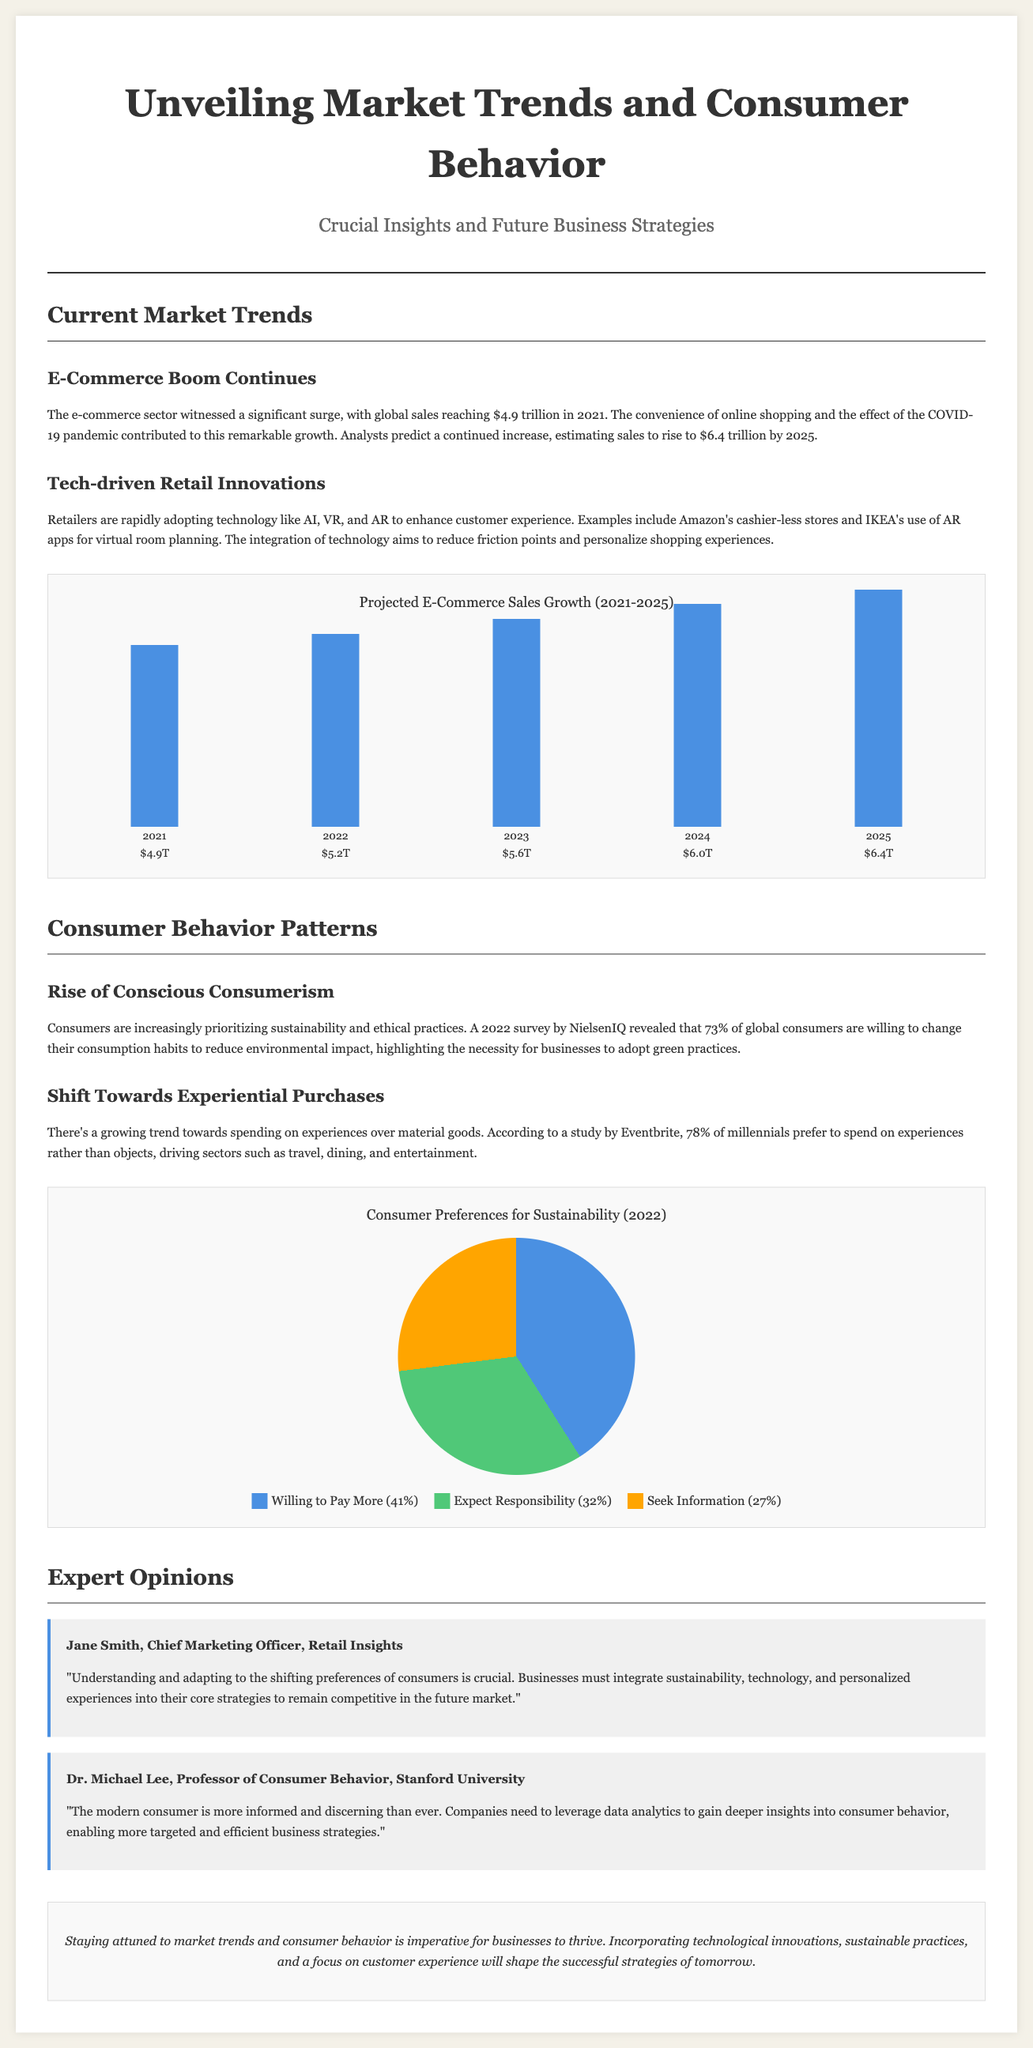What was the global e-commerce sales amount in 2021? The document states that global sales reached $4.9 trillion in 2021.
Answer: $4.9 trillion What is the projected e-commerce sales figure for 2025? According to the analysis, the sales are estimated to rise to $6.4 trillion by 2025.
Answer: $6.4 trillion What percentage of global consumers are willing to change their consumption habits for sustainability? The survey reveals that 73% of global consumers are willing to change their habits.
Answer: 73% What is the preference of 78% of millennials regarding spending habits? The document mentions that 78% of millennials prefer to spend on experiences over objects.
Answer: Experiences Who is the Chief Marketing Officer mentioned in the expert opinions? Jane Smith is identified as the Chief Marketing Officer in the document.
Answer: Jane Smith What are retail technologies mentioned that enhance customer experience? The document lists AI, VR, and AR as technologies enhancing customer experience.
Answer: AI, VR, AR Which year showed the highest projected e-commerce sales growth in the chart? The chart indicates that 2025 will have the highest projected sales growth at $6.4 trillion.
Answer: 2025 What does the pie chart represent about consumer preferences for sustainability? The pie chart represents percentages regarding consumers' willingness to pay more, expectations of responsibility, and need for information about sustainability.
Answer: Sustainability Preferences What does Dr. Michael Lee emphasize regarding companies and consumer behavior? Dr. Michael Lee emphasizes that companies need to leverage data analytics to gain deeper insights into consumer behavior.
Answer: Data analytics 